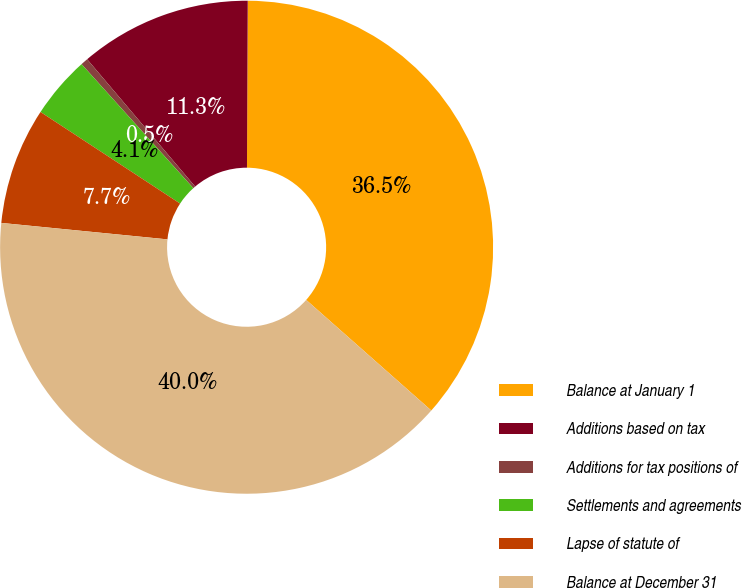Convert chart to OTSL. <chart><loc_0><loc_0><loc_500><loc_500><pie_chart><fcel>Balance at January 1<fcel>Additions based on tax<fcel>Additions for tax positions of<fcel>Settlements and agreements<fcel>Lapse of statute of<fcel>Balance at December 31<nl><fcel>36.45%<fcel>11.27%<fcel>0.48%<fcel>4.08%<fcel>7.67%<fcel>40.05%<nl></chart> 